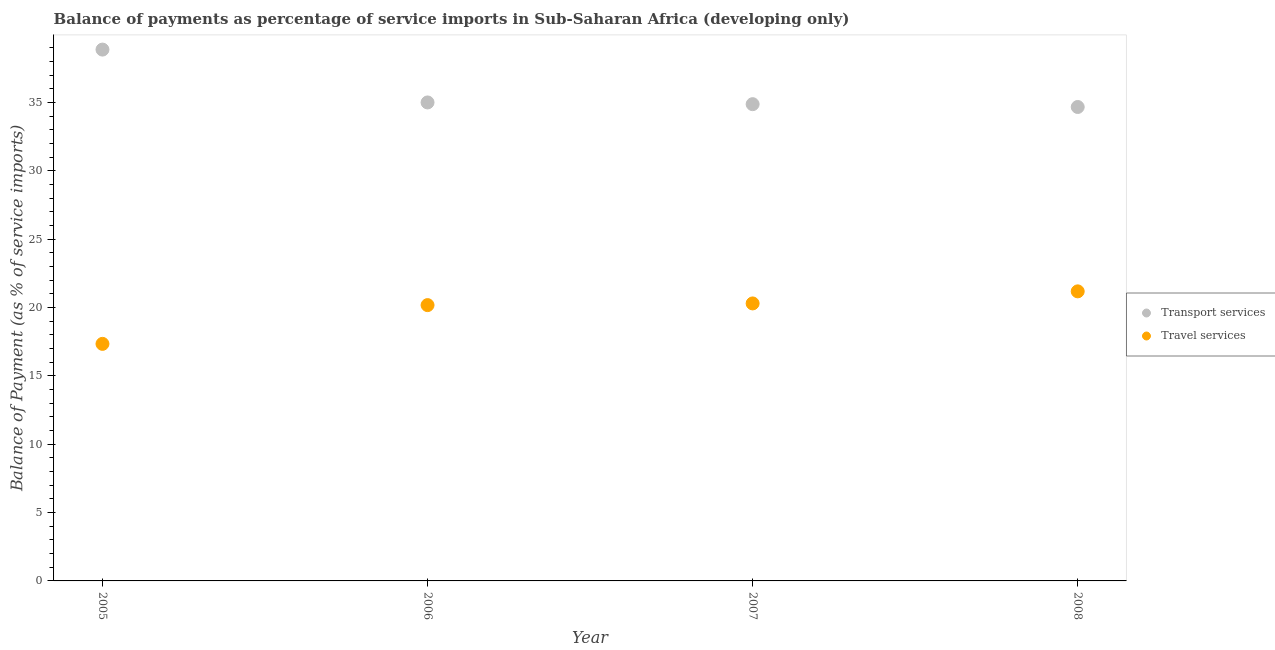What is the balance of payments of travel services in 2006?
Offer a terse response. 20.18. Across all years, what is the maximum balance of payments of transport services?
Your answer should be very brief. 38.87. Across all years, what is the minimum balance of payments of travel services?
Ensure brevity in your answer.  17.34. In which year was the balance of payments of travel services maximum?
Your answer should be very brief. 2008. What is the total balance of payments of transport services in the graph?
Offer a very short reply. 143.43. What is the difference between the balance of payments of transport services in 2005 and that in 2008?
Provide a succinct answer. 4.2. What is the difference between the balance of payments of transport services in 2006 and the balance of payments of travel services in 2008?
Offer a very short reply. 13.82. What is the average balance of payments of travel services per year?
Your answer should be very brief. 19.75. In the year 2008, what is the difference between the balance of payments of transport services and balance of payments of travel services?
Your answer should be very brief. 13.49. What is the ratio of the balance of payments of travel services in 2007 to that in 2008?
Provide a succinct answer. 0.96. Is the balance of payments of transport services in 2005 less than that in 2006?
Offer a terse response. No. Is the difference between the balance of payments of transport services in 2005 and 2007 greater than the difference between the balance of payments of travel services in 2005 and 2007?
Provide a succinct answer. Yes. What is the difference between the highest and the second highest balance of payments of transport services?
Ensure brevity in your answer.  3.87. What is the difference between the highest and the lowest balance of payments of transport services?
Give a very brief answer. 4.2. In how many years, is the balance of payments of transport services greater than the average balance of payments of transport services taken over all years?
Keep it short and to the point. 1. Does the balance of payments of transport services monotonically increase over the years?
Ensure brevity in your answer.  No. Is the balance of payments of travel services strictly greater than the balance of payments of transport services over the years?
Offer a terse response. No. How many dotlines are there?
Make the answer very short. 2. How many years are there in the graph?
Offer a very short reply. 4. What is the difference between two consecutive major ticks on the Y-axis?
Provide a succinct answer. 5. Are the values on the major ticks of Y-axis written in scientific E-notation?
Provide a short and direct response. No. Where does the legend appear in the graph?
Keep it short and to the point. Center right. How are the legend labels stacked?
Keep it short and to the point. Vertical. What is the title of the graph?
Offer a very short reply. Balance of payments as percentage of service imports in Sub-Saharan Africa (developing only). Does "Frequency of shipment arrival" appear as one of the legend labels in the graph?
Provide a succinct answer. No. What is the label or title of the X-axis?
Your answer should be compact. Year. What is the label or title of the Y-axis?
Offer a terse response. Balance of Payment (as % of service imports). What is the Balance of Payment (as % of service imports) in Transport services in 2005?
Provide a short and direct response. 38.87. What is the Balance of Payment (as % of service imports) of Travel services in 2005?
Give a very brief answer. 17.34. What is the Balance of Payment (as % of service imports) in Transport services in 2006?
Keep it short and to the point. 35. What is the Balance of Payment (as % of service imports) in Travel services in 2006?
Provide a short and direct response. 20.18. What is the Balance of Payment (as % of service imports) of Transport services in 2007?
Provide a short and direct response. 34.88. What is the Balance of Payment (as % of service imports) in Travel services in 2007?
Offer a terse response. 20.3. What is the Balance of Payment (as % of service imports) in Transport services in 2008?
Provide a succinct answer. 34.67. What is the Balance of Payment (as % of service imports) of Travel services in 2008?
Give a very brief answer. 21.18. Across all years, what is the maximum Balance of Payment (as % of service imports) of Transport services?
Offer a terse response. 38.87. Across all years, what is the maximum Balance of Payment (as % of service imports) in Travel services?
Provide a succinct answer. 21.18. Across all years, what is the minimum Balance of Payment (as % of service imports) in Transport services?
Provide a succinct answer. 34.67. Across all years, what is the minimum Balance of Payment (as % of service imports) in Travel services?
Provide a succinct answer. 17.34. What is the total Balance of Payment (as % of service imports) in Transport services in the graph?
Your response must be concise. 143.43. What is the total Balance of Payment (as % of service imports) in Travel services in the graph?
Provide a short and direct response. 79. What is the difference between the Balance of Payment (as % of service imports) of Transport services in 2005 and that in 2006?
Provide a succinct answer. 3.87. What is the difference between the Balance of Payment (as % of service imports) in Travel services in 2005 and that in 2006?
Make the answer very short. -2.84. What is the difference between the Balance of Payment (as % of service imports) of Transport services in 2005 and that in 2007?
Ensure brevity in your answer.  3.99. What is the difference between the Balance of Payment (as % of service imports) in Travel services in 2005 and that in 2007?
Provide a succinct answer. -2.96. What is the difference between the Balance of Payment (as % of service imports) in Transport services in 2005 and that in 2008?
Your answer should be very brief. 4.2. What is the difference between the Balance of Payment (as % of service imports) in Travel services in 2005 and that in 2008?
Make the answer very short. -3.84. What is the difference between the Balance of Payment (as % of service imports) in Transport services in 2006 and that in 2007?
Make the answer very short. 0.13. What is the difference between the Balance of Payment (as % of service imports) in Travel services in 2006 and that in 2007?
Your response must be concise. -0.12. What is the difference between the Balance of Payment (as % of service imports) of Transport services in 2006 and that in 2008?
Your answer should be very brief. 0.33. What is the difference between the Balance of Payment (as % of service imports) of Travel services in 2006 and that in 2008?
Keep it short and to the point. -1.01. What is the difference between the Balance of Payment (as % of service imports) in Transport services in 2007 and that in 2008?
Provide a succinct answer. 0.21. What is the difference between the Balance of Payment (as % of service imports) of Travel services in 2007 and that in 2008?
Make the answer very short. -0.88. What is the difference between the Balance of Payment (as % of service imports) in Transport services in 2005 and the Balance of Payment (as % of service imports) in Travel services in 2006?
Make the answer very short. 18.69. What is the difference between the Balance of Payment (as % of service imports) in Transport services in 2005 and the Balance of Payment (as % of service imports) in Travel services in 2007?
Make the answer very short. 18.57. What is the difference between the Balance of Payment (as % of service imports) in Transport services in 2005 and the Balance of Payment (as % of service imports) in Travel services in 2008?
Provide a succinct answer. 17.69. What is the difference between the Balance of Payment (as % of service imports) in Transport services in 2006 and the Balance of Payment (as % of service imports) in Travel services in 2007?
Ensure brevity in your answer.  14.7. What is the difference between the Balance of Payment (as % of service imports) of Transport services in 2006 and the Balance of Payment (as % of service imports) of Travel services in 2008?
Provide a short and direct response. 13.82. What is the difference between the Balance of Payment (as % of service imports) in Transport services in 2007 and the Balance of Payment (as % of service imports) in Travel services in 2008?
Offer a very short reply. 13.69. What is the average Balance of Payment (as % of service imports) in Transport services per year?
Provide a short and direct response. 35.86. What is the average Balance of Payment (as % of service imports) of Travel services per year?
Offer a terse response. 19.75. In the year 2005, what is the difference between the Balance of Payment (as % of service imports) in Transport services and Balance of Payment (as % of service imports) in Travel services?
Give a very brief answer. 21.53. In the year 2006, what is the difference between the Balance of Payment (as % of service imports) of Transport services and Balance of Payment (as % of service imports) of Travel services?
Keep it short and to the point. 14.83. In the year 2007, what is the difference between the Balance of Payment (as % of service imports) of Transport services and Balance of Payment (as % of service imports) of Travel services?
Your response must be concise. 14.58. In the year 2008, what is the difference between the Balance of Payment (as % of service imports) of Transport services and Balance of Payment (as % of service imports) of Travel services?
Provide a succinct answer. 13.49. What is the ratio of the Balance of Payment (as % of service imports) of Transport services in 2005 to that in 2006?
Your response must be concise. 1.11. What is the ratio of the Balance of Payment (as % of service imports) in Travel services in 2005 to that in 2006?
Your response must be concise. 0.86. What is the ratio of the Balance of Payment (as % of service imports) of Transport services in 2005 to that in 2007?
Make the answer very short. 1.11. What is the ratio of the Balance of Payment (as % of service imports) of Travel services in 2005 to that in 2007?
Ensure brevity in your answer.  0.85. What is the ratio of the Balance of Payment (as % of service imports) of Transport services in 2005 to that in 2008?
Offer a terse response. 1.12. What is the ratio of the Balance of Payment (as % of service imports) in Travel services in 2005 to that in 2008?
Your response must be concise. 0.82. What is the ratio of the Balance of Payment (as % of service imports) of Transport services in 2006 to that in 2007?
Your answer should be compact. 1. What is the ratio of the Balance of Payment (as % of service imports) in Transport services in 2006 to that in 2008?
Provide a short and direct response. 1.01. What is the ratio of the Balance of Payment (as % of service imports) of Travel services in 2006 to that in 2008?
Offer a terse response. 0.95. What is the ratio of the Balance of Payment (as % of service imports) in Transport services in 2007 to that in 2008?
Ensure brevity in your answer.  1.01. What is the difference between the highest and the second highest Balance of Payment (as % of service imports) of Transport services?
Provide a succinct answer. 3.87. What is the difference between the highest and the second highest Balance of Payment (as % of service imports) in Travel services?
Your answer should be very brief. 0.88. What is the difference between the highest and the lowest Balance of Payment (as % of service imports) of Transport services?
Your answer should be compact. 4.2. What is the difference between the highest and the lowest Balance of Payment (as % of service imports) of Travel services?
Offer a very short reply. 3.84. 